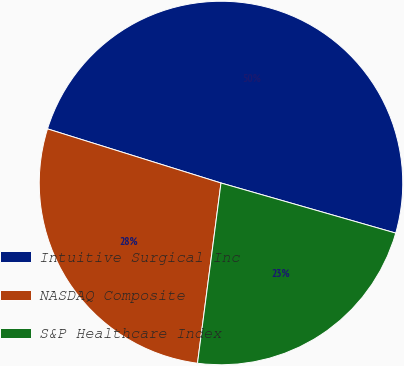<chart> <loc_0><loc_0><loc_500><loc_500><pie_chart><fcel>Intuitive Surgical Inc<fcel>NASDAQ Composite<fcel>S&P Healthcare Index<nl><fcel>49.63%<fcel>27.75%<fcel>22.62%<nl></chart> 